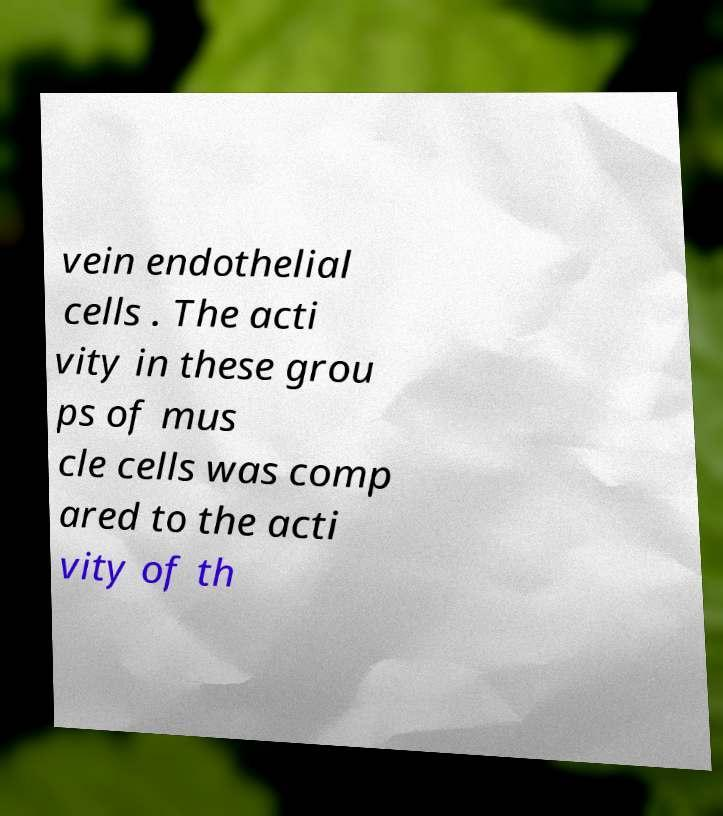Can you read and provide the text displayed in the image?This photo seems to have some interesting text. Can you extract and type it out for me? vein endothelial cells . The acti vity in these grou ps of mus cle cells was comp ared to the acti vity of th 